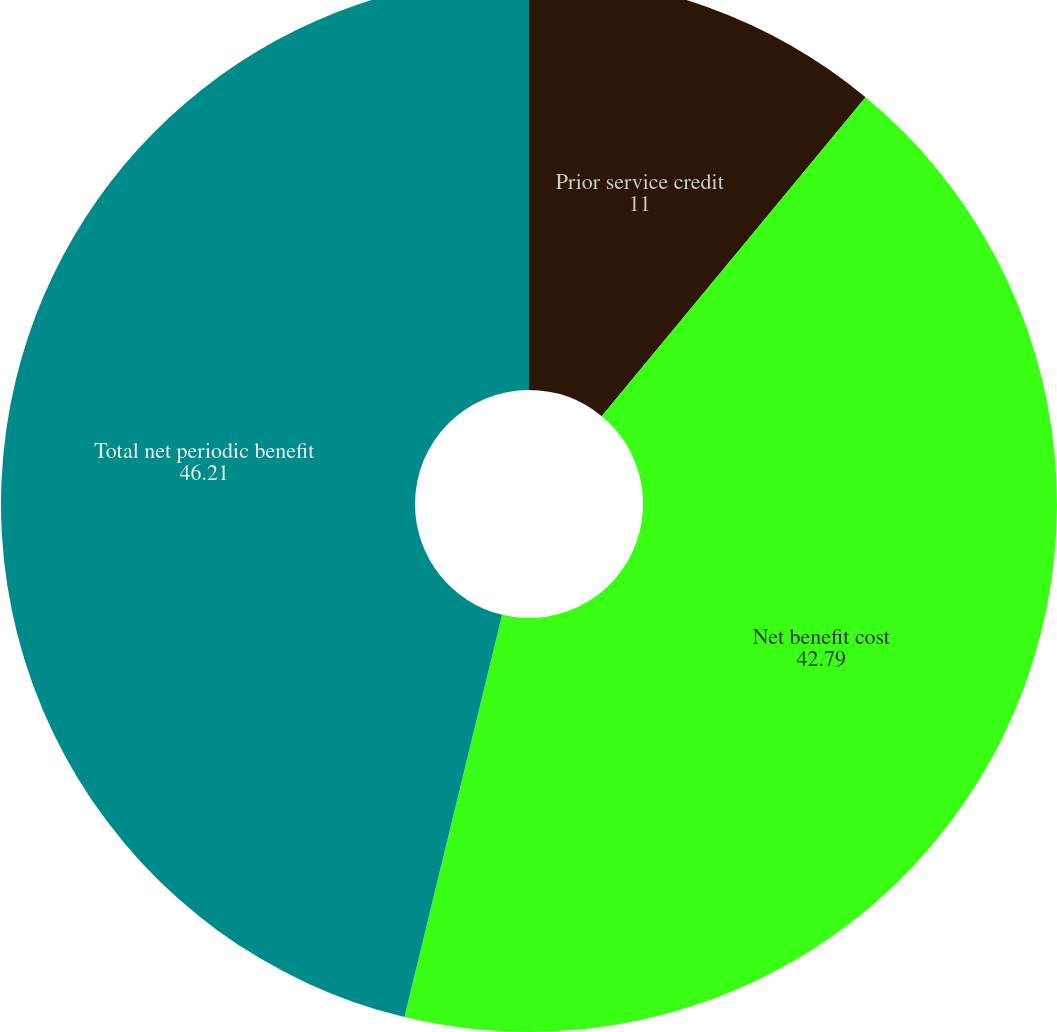Convert chart. <chart><loc_0><loc_0><loc_500><loc_500><pie_chart><fcel>Prior service credit<fcel>Net benefit cost<fcel>Total net periodic benefit<nl><fcel>11.0%<fcel>42.79%<fcel>46.21%<nl></chart> 